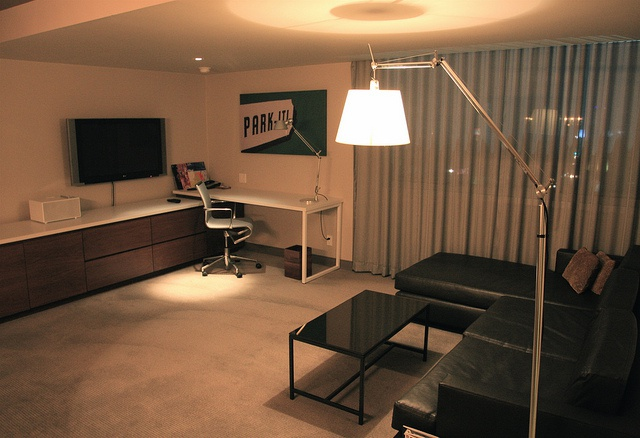Describe the objects in this image and their specific colors. I can see couch in black and gray tones, tv in black, maroon, and brown tones, dining table in black, maroon, and gray tones, chair in black and gray tones, and book in black and brown tones in this image. 